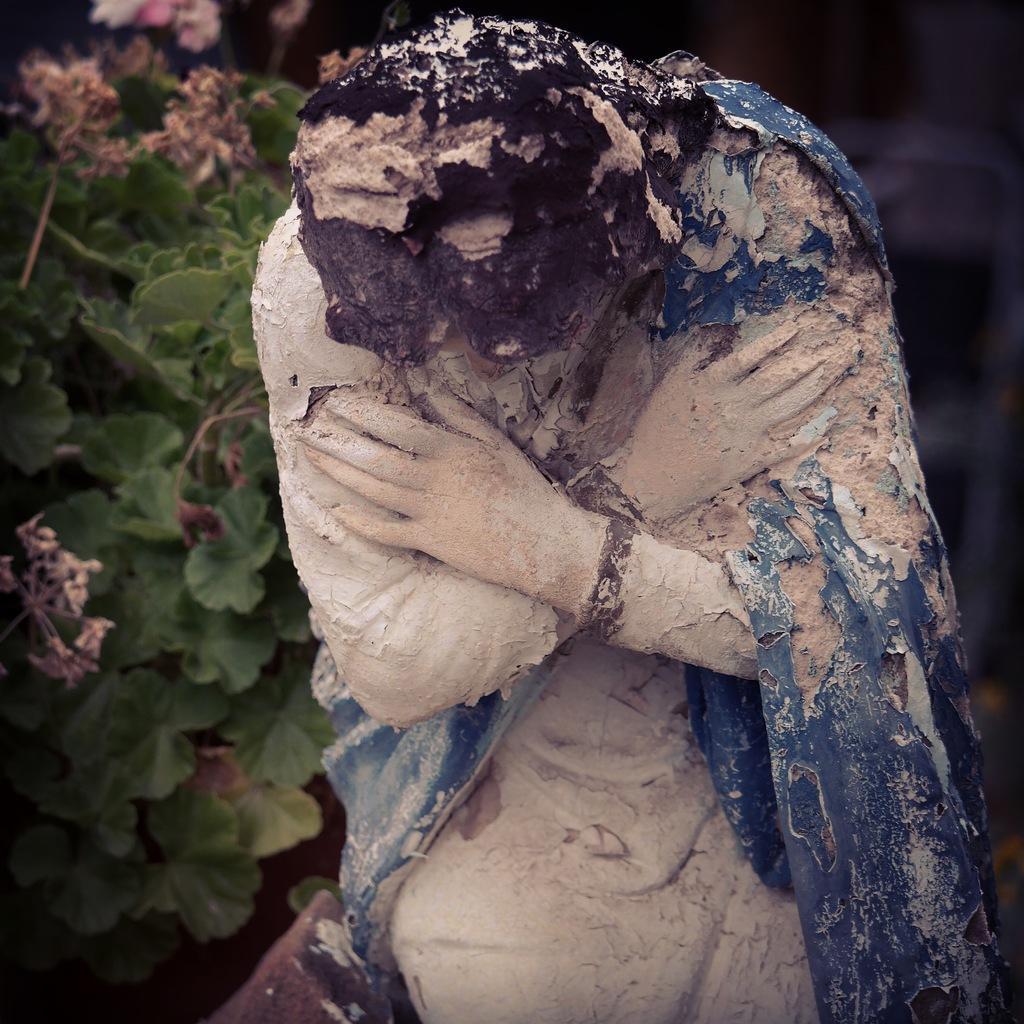How would you summarize this image in a sentence or two? In the picture we can see there is sculpture and in the background there is plant which has leaves. 